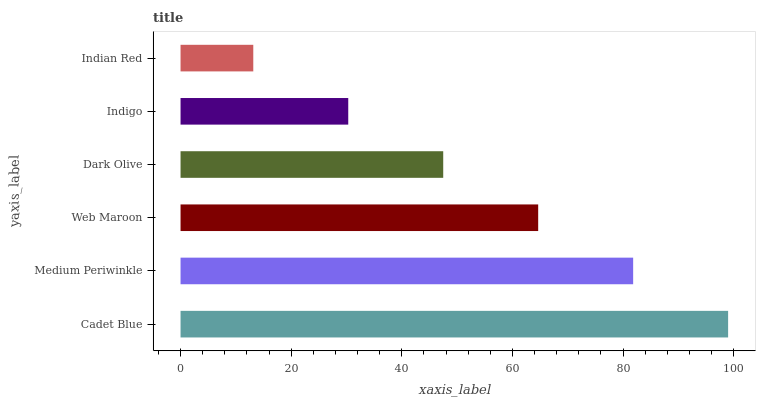Is Indian Red the minimum?
Answer yes or no. Yes. Is Cadet Blue the maximum?
Answer yes or no. Yes. Is Medium Periwinkle the minimum?
Answer yes or no. No. Is Medium Periwinkle the maximum?
Answer yes or no. No. Is Cadet Blue greater than Medium Periwinkle?
Answer yes or no. Yes. Is Medium Periwinkle less than Cadet Blue?
Answer yes or no. Yes. Is Medium Periwinkle greater than Cadet Blue?
Answer yes or no. No. Is Cadet Blue less than Medium Periwinkle?
Answer yes or no. No. Is Web Maroon the high median?
Answer yes or no. Yes. Is Dark Olive the low median?
Answer yes or no. Yes. Is Dark Olive the high median?
Answer yes or no. No. Is Web Maroon the low median?
Answer yes or no. No. 